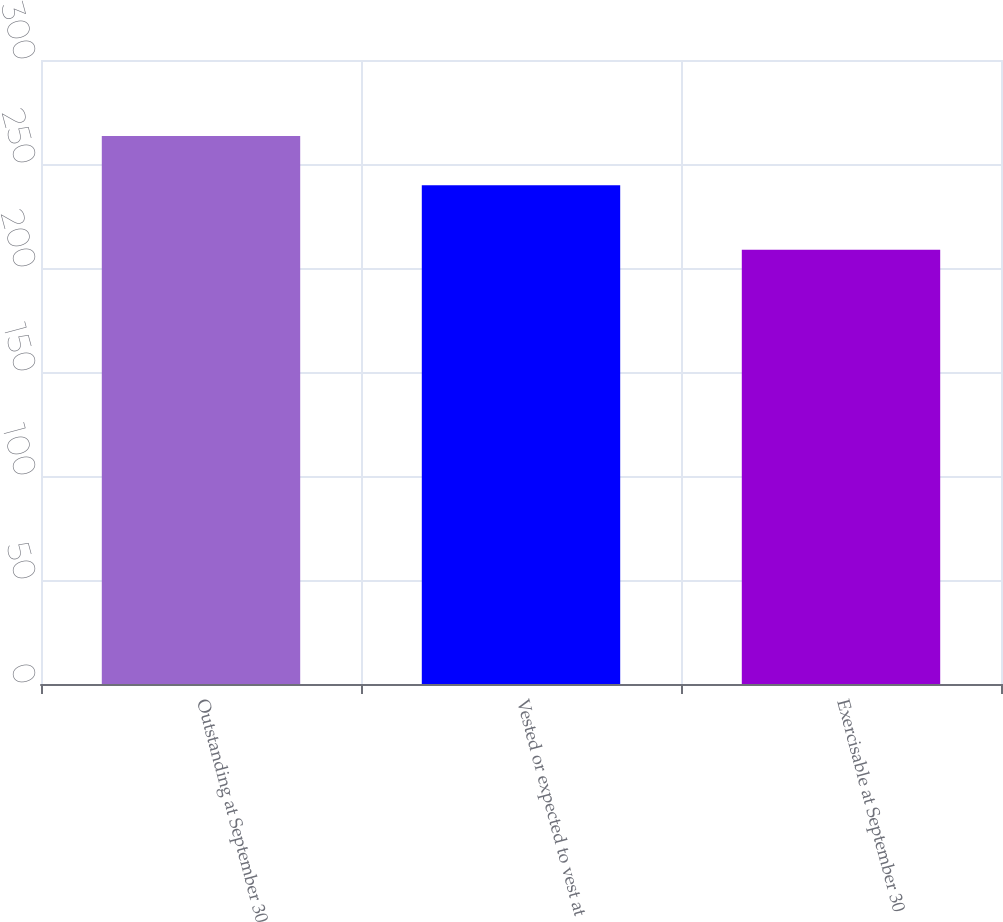Convert chart to OTSL. <chart><loc_0><loc_0><loc_500><loc_500><bar_chart><fcel>Outstanding at September 30<fcel>Vested or expected to vest at<fcel>Exercisable at September 30<nl><fcel>263.45<fcel>239.75<fcel>208.75<nl></chart> 